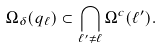<formula> <loc_0><loc_0><loc_500><loc_500>\Omega _ { \delta } ( q _ { \ell } ) \subset \bigcap _ { \ell ^ { \prime } \not = \ell } \Omega ^ { c } ( \ell ^ { \prime } ) .</formula> 